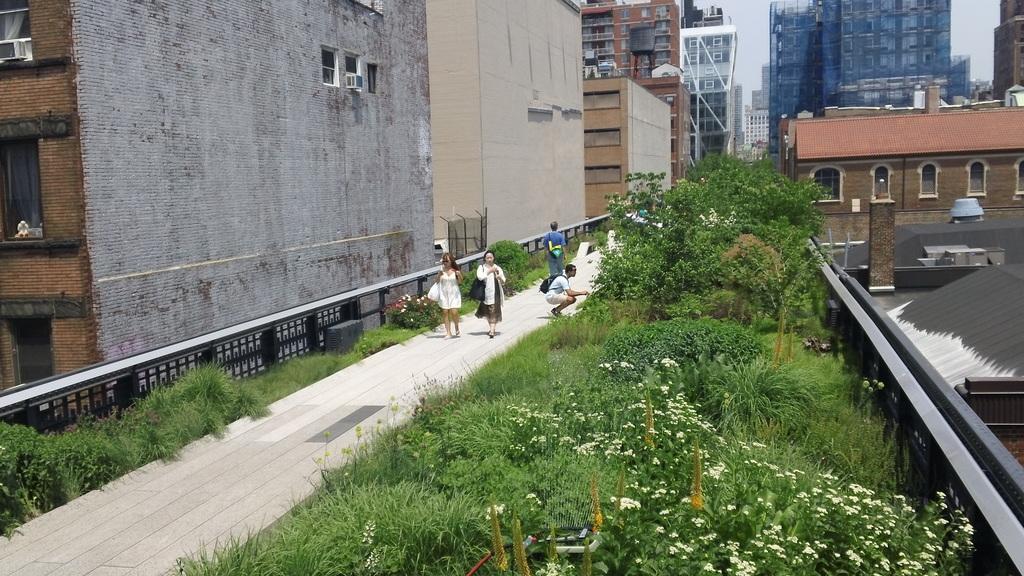Can you describe this image briefly? In the foreground of the picture we can see plants, trees, people, flowers and other objects. On the left there are shrubs, railing and building. In the middle of the picture there are buildings. In the background it is sky. 